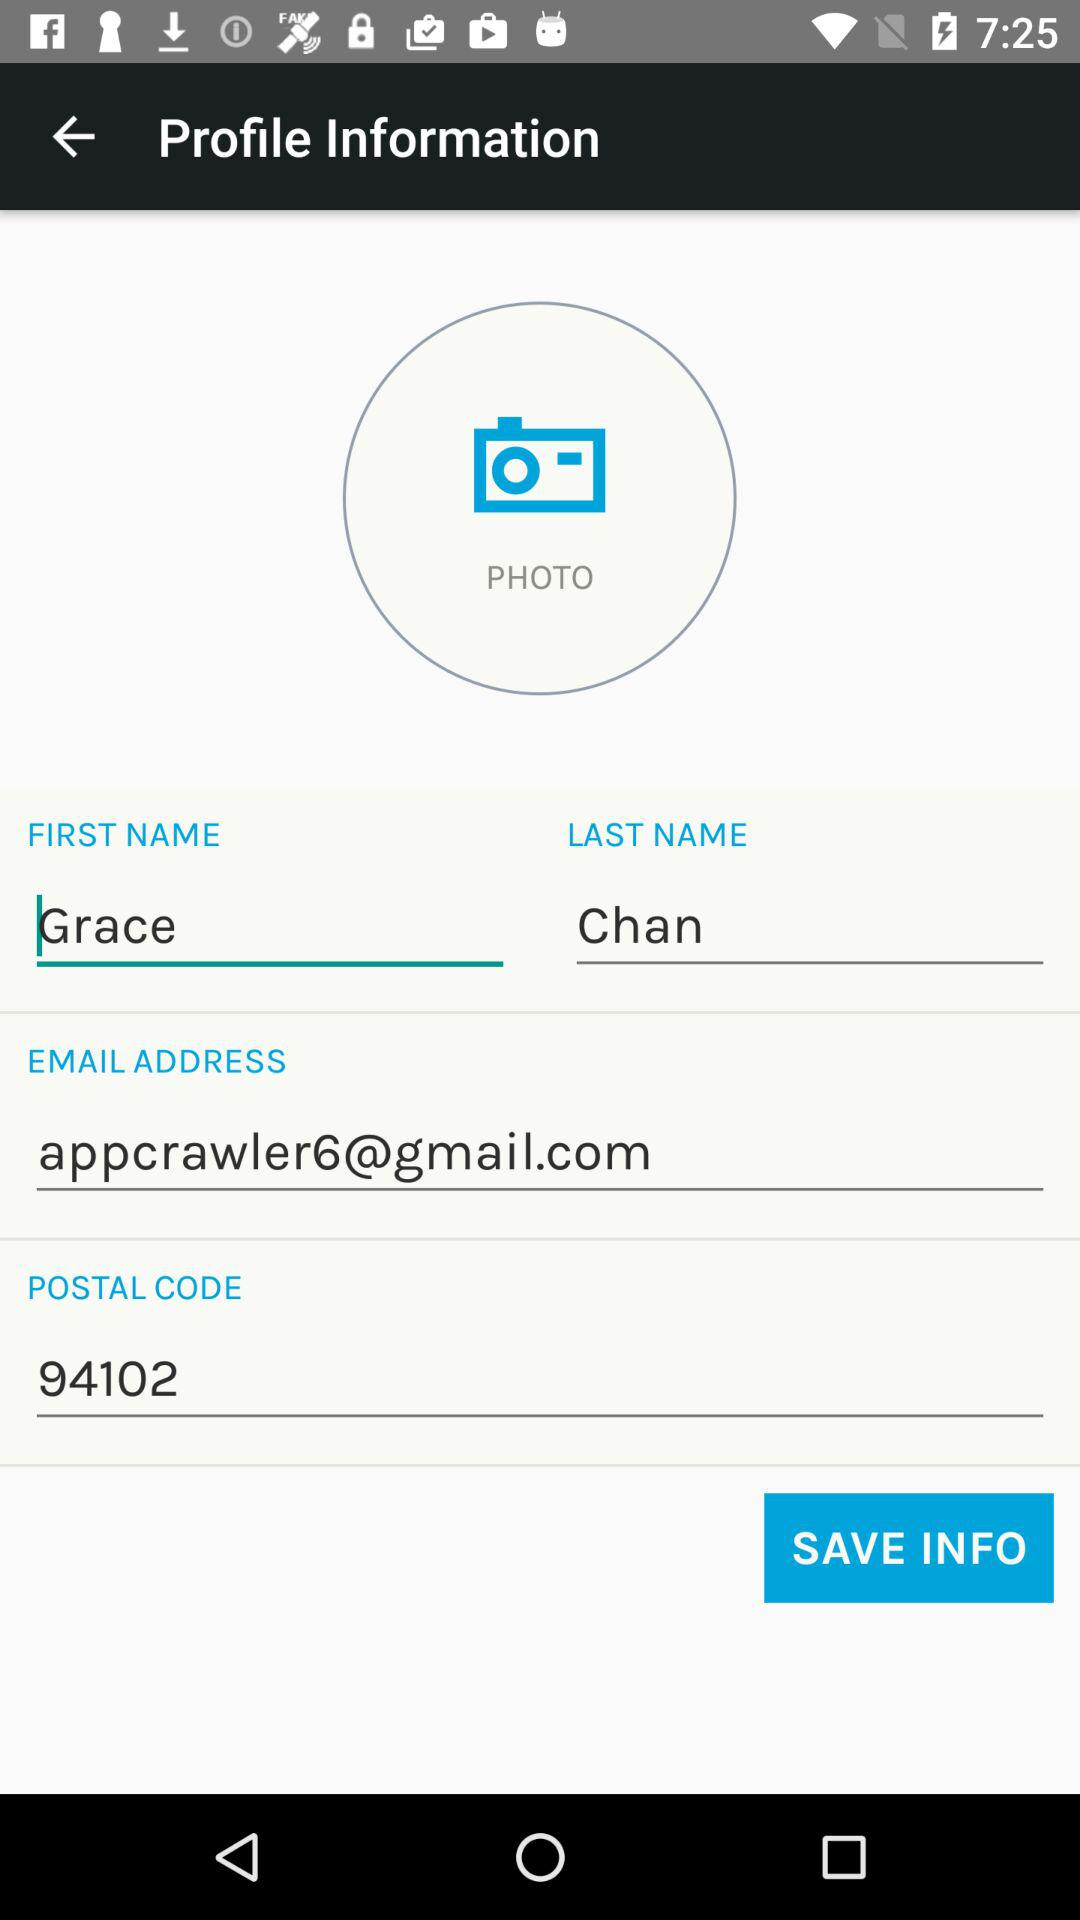What is the last name? The last name is Chan. 